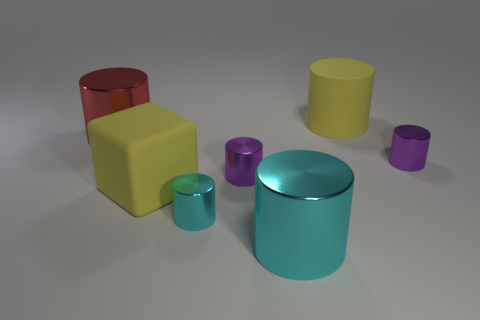There is a yellow matte object behind the red cylinder; does it have the same size as the small cyan metallic object?
Offer a very short reply. No. Are there more big rubber things than large yellow rubber cylinders?
Make the answer very short. Yes. Is there a yellow thing that has the same shape as the big cyan object?
Give a very brief answer. Yes. There is a big matte thing that is behind the yellow rubber cube; what is its shape?
Ensure brevity in your answer.  Cylinder. There is a matte thing in front of the thing on the right side of the big yellow matte cylinder; what number of cylinders are behind it?
Ensure brevity in your answer.  4. There is a large thing behind the red thing; is it the same color as the matte cube?
Offer a terse response. Yes. How many other objects are the same shape as the big red object?
Offer a terse response. 5. How many other objects are there of the same material as the tiny cyan cylinder?
Offer a terse response. 4. What material is the big thing that is right of the big metal object that is to the right of the big yellow matte thing that is to the left of the large yellow matte cylinder made of?
Offer a very short reply. Rubber. Are the small cyan cylinder and the cube made of the same material?
Provide a short and direct response. No. 